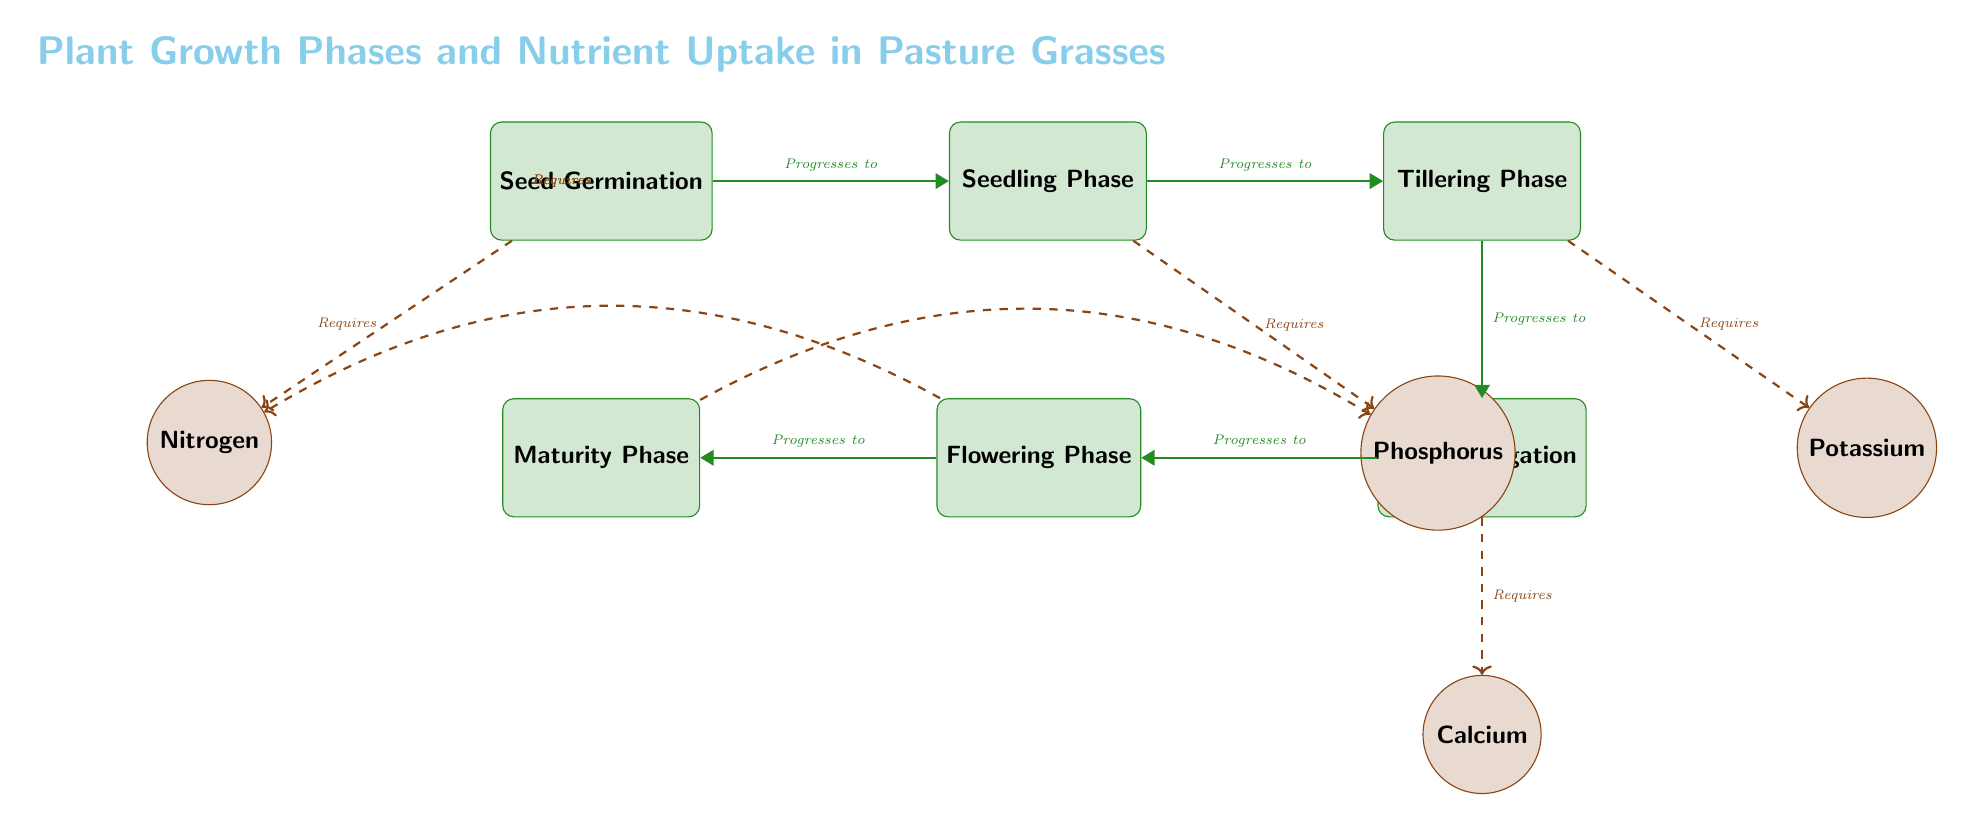What is the first growth phase depicted in the diagram? The diagram shows a sequence of growth phases, starting from "Seed Germination" as the first phase on the left.
Answer: Seed Germination How many growth phases are included in the diagram? The diagram lists a total of five growth phases: Seed Germination, Seedling Phase, Tillering Phase, Stem Elongation, Flowering Phase, and Maturity Phase, making it six in total.
Answer: 6 Which nutrient is required during the Seed Germination phase? The diagram indicates that "Nitrogen" is the nutrient required for the Seed Germination phase, as it is connected directly to this phase with a dashed line labelled "Requires".
Answer: Nitrogen What growth phase follows the Seedling Phase? The diagram shows a flow from the Seedling Phase to the Tillering Phase, where the arrow states "Progresses to", indicating that Tillering follows Seedling.
Answer: Tillering Phase Which nutrient is required during both the Flowering and Maturity phases? The diagram connects the Flowering Phase and Maturity Phase to Phosphorus nutrient requirements. The flowering phase requires nitrogen but also connects back to phosphorus, indicating both phases require Phosphorus.
Answer: Phosphorus How many nutrients are depicted in the diagram? The diagram depicts four distinct nutrients connected to the growth phases, namely Nitrogen, Phosphorus, Potassium, and Calcium.
Answer: 4 Which nutrient is not directly required in the maturity phase? By examining the connections, we see that the Maturity Phase is connected only to Phosphorus and does not require Nitrogen or Potassium in its direct line.
Answer: Nitrogen What is the final growth phase listed in the diagram? The sequence of growth phases ends with "Maturity Phase", which is the last phase shown on the right side of the diagram.
Answer: Maturity Phase Which growth phase requires Calcium? The diagram indicates that Calcium is required during the Stem Elongation phase, as shown by a dashed line labeled "Requires" pointing from the Stem Elongation to Calcium.
Answer: Stem Elongation 